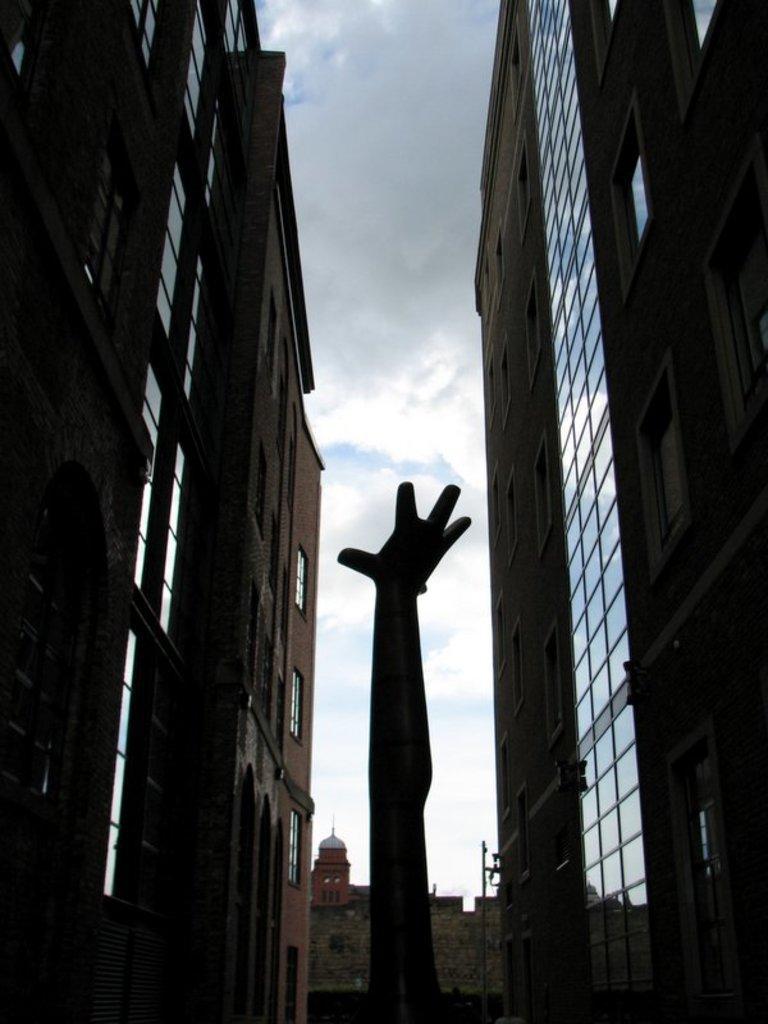Can you describe this image briefly? In this image, we can see a few buildings. We can also see a statue. We can see the wall and the sky with clouds. 